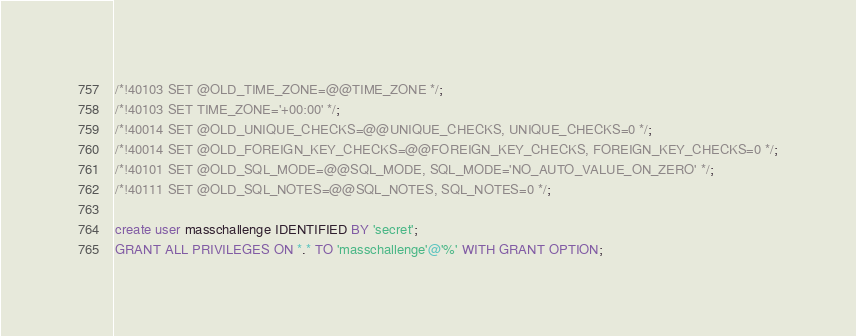Convert code to text. <code><loc_0><loc_0><loc_500><loc_500><_SQL_>/*!40103 SET @OLD_TIME_ZONE=@@TIME_ZONE */;
/*!40103 SET TIME_ZONE='+00:00' */;
/*!40014 SET @OLD_UNIQUE_CHECKS=@@UNIQUE_CHECKS, UNIQUE_CHECKS=0 */;
/*!40014 SET @OLD_FOREIGN_KEY_CHECKS=@@FOREIGN_KEY_CHECKS, FOREIGN_KEY_CHECKS=0 */;
/*!40101 SET @OLD_SQL_MODE=@@SQL_MODE, SQL_MODE='NO_AUTO_VALUE_ON_ZERO' */;
/*!40111 SET @OLD_SQL_NOTES=@@SQL_NOTES, SQL_NOTES=0 */;

create user masschallenge IDENTIFIED BY 'secret';
GRANT ALL PRIVILEGES ON *.* TO 'masschallenge'@'%' WITH GRANT OPTION;</code> 